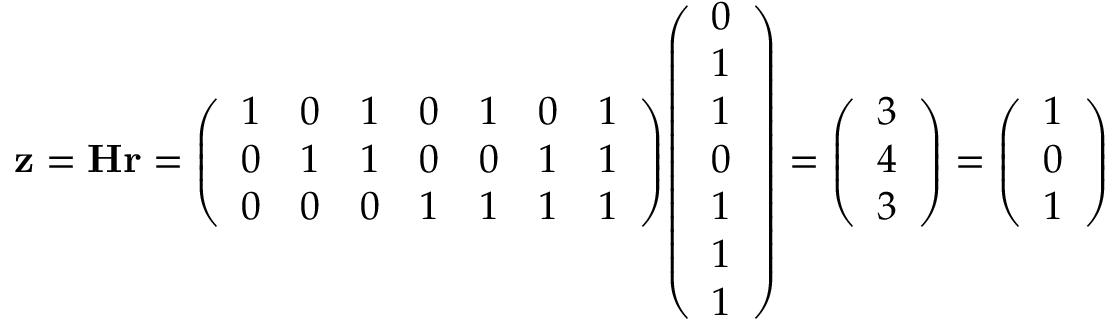<formula> <loc_0><loc_0><loc_500><loc_500>z = H r = { \left ( \begin{array} { l l l l l l l } { 1 } & { 0 } & { 1 } & { 0 } & { 1 } & { 0 } & { 1 } \\ { 0 } & { 1 } & { 1 } & { 0 } & { 0 } & { 1 } & { 1 } \\ { 0 } & { 0 } & { 0 } & { 1 } & { 1 } & { 1 } & { 1 } \end{array} \right ) } { \left ( \begin{array} { l } { 0 } \\ { 1 } \\ { 1 } \\ { 0 } \\ { 1 } \\ { 1 } \\ { 1 } \end{array} \right ) } = { \left ( \begin{array} { l } { 3 } \\ { 4 } \\ { 3 } \end{array} \right ) } = { \left ( \begin{array} { l } { 1 } \\ { 0 } \\ { 1 } \end{array} \right ) }</formula> 